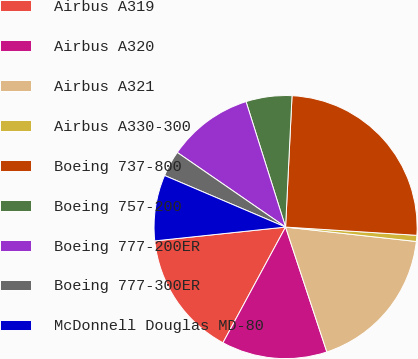Convert chart to OTSL. <chart><loc_0><loc_0><loc_500><loc_500><pie_chart><fcel>Airbus A319<fcel>Airbus A320<fcel>Airbus A321<fcel>Airbus A330-300<fcel>Boeing 737-800<fcel>Boeing 757-200<fcel>Boeing 777-200ER<fcel>Boeing 777-300ER<fcel>McDonnell Douglas MD-80<nl><fcel>15.43%<fcel>12.98%<fcel>18.17%<fcel>0.75%<fcel>25.22%<fcel>5.64%<fcel>10.54%<fcel>3.19%<fcel>8.09%<nl></chart> 